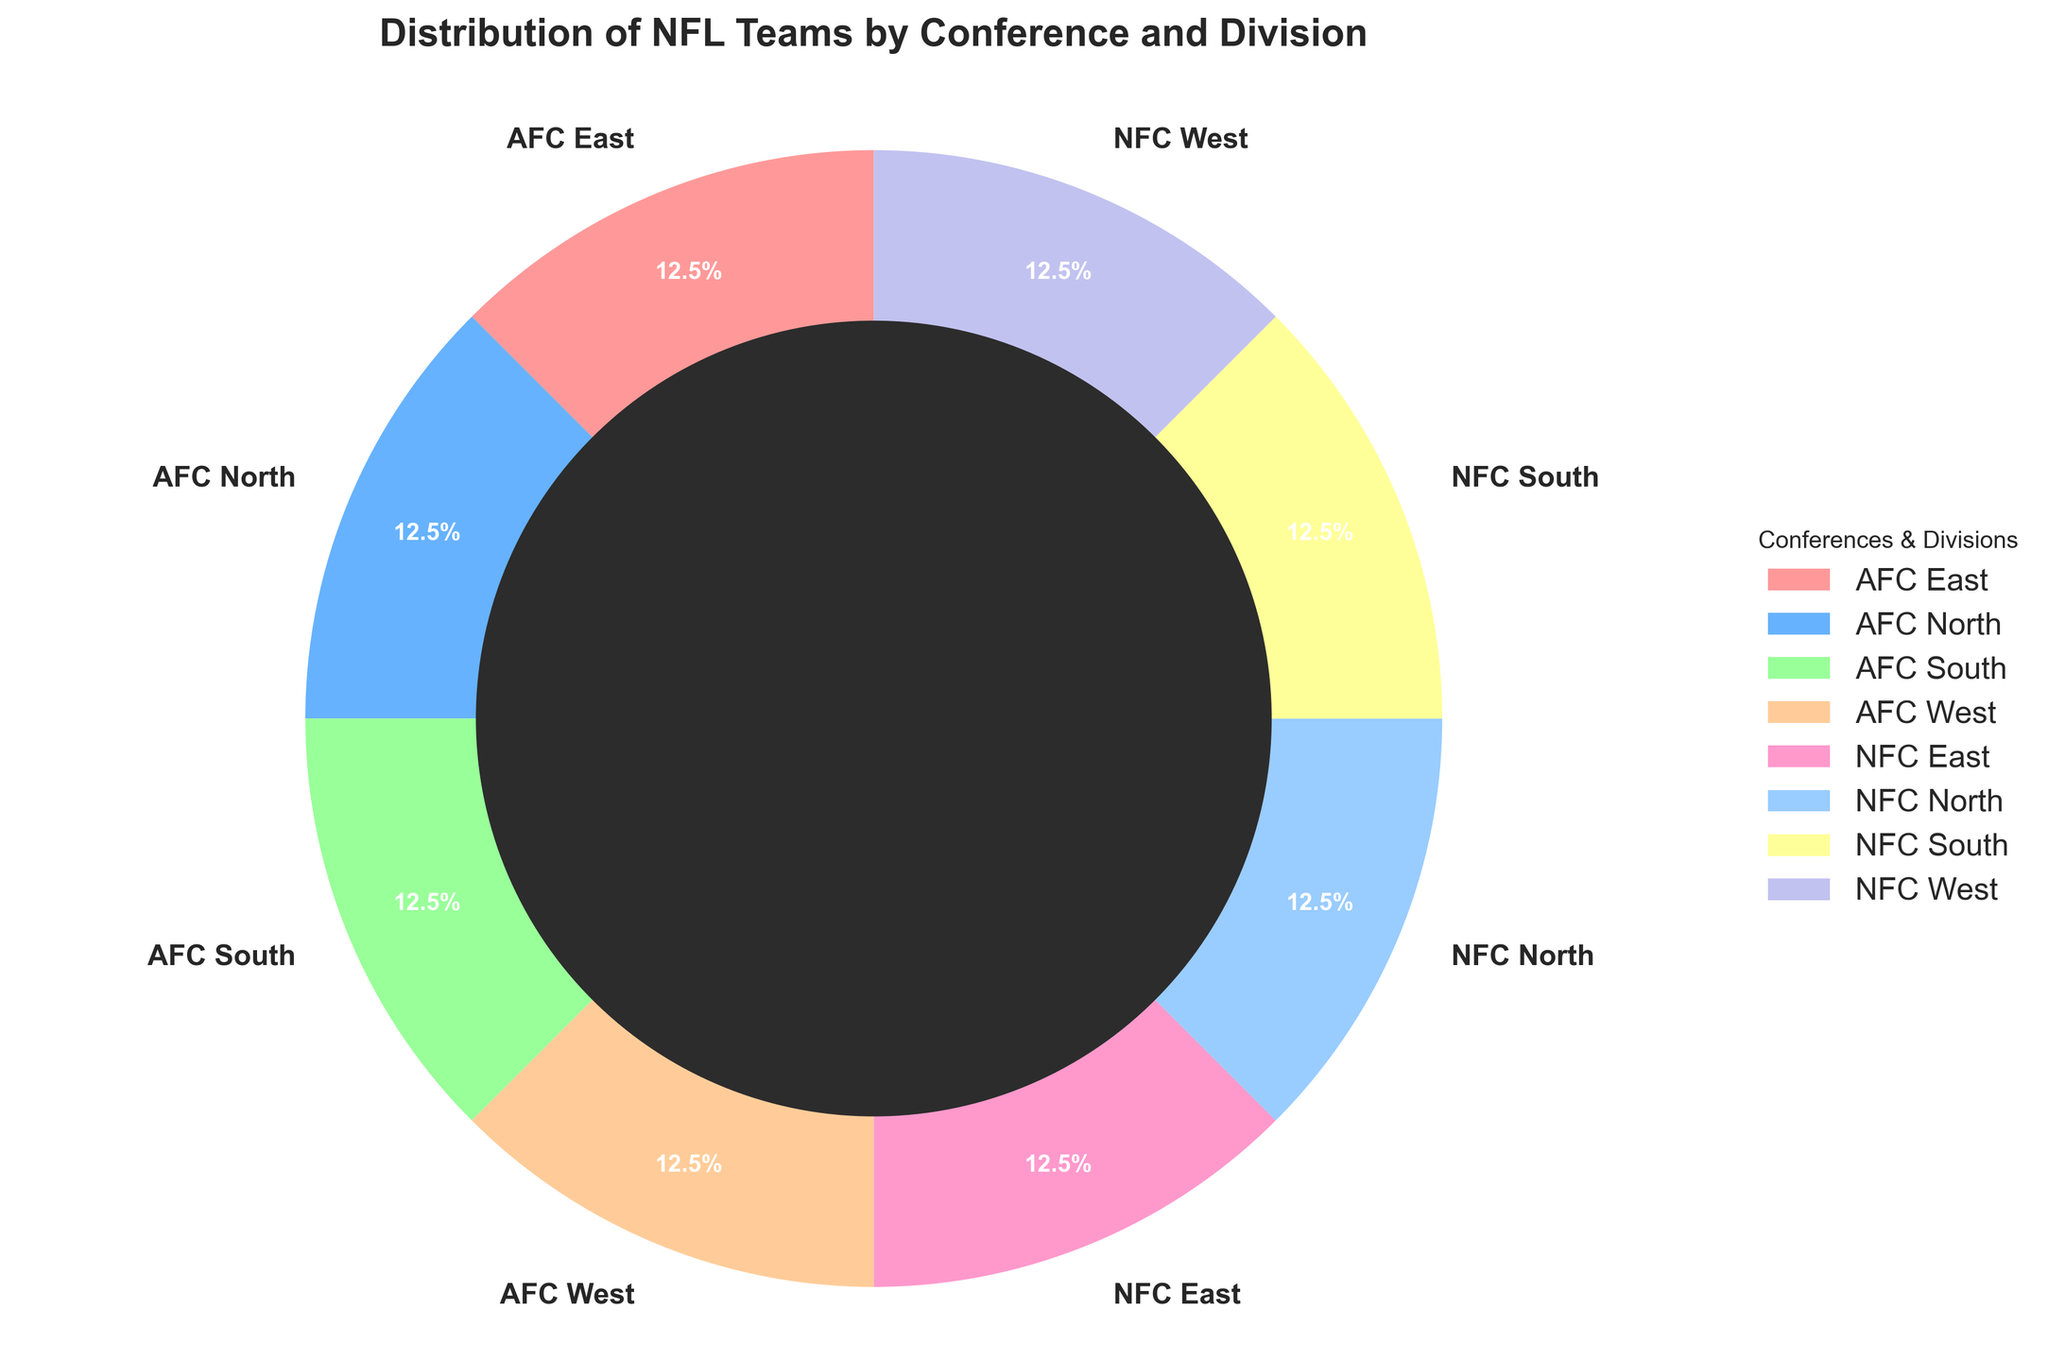what is the percentage of AFC teams? Adding up the AFC divisions (AFC East, AFC North, AFC South, and AFC West), there are 4 teams each, making a total of 16 teams. The total number of teams in the pie chart is 32, so the percentage is (16/32) * 100.
Answer: 50% What is the percentage of NFC East teams? Each division has 4 teams, and since NFC East is one division out of the 8 total divisions, it has (4/32) * 100 percent representation in the pie chart.
Answer: 12.5% How many teams belong to the South divisions across both conferences? Adding the teams from AFC South (4 teams) and NFC South (4 teams), we have a total of 4 + 4 teams in the South divisions.
Answer: 8 Which divisions have the same number of teams? All divisions (AFC East, AFC North, AFC South, AFC West, NFC East, NFC North, NFC South, NFC West) have the same number of teams, which is 4.
Answer: All divisions What is the combined percentage of the East divisions? The AFC East and NFC East each have 4 teams. So together, they make up 8 teams out of the total 32 teams. The percentage is (8/32) * 100.
Answer: 25% Which segment has a color representing NFC North? Based on the custom colors and labels provided, the NFC North segment can be identified visually in the pie chart.
Answer: Light blue Which divisions occupy the largest and smallest segments? Since all divisions have the same number of teams (4), they have equal-sized segments in the pie chart.
Answer: All divisions are equal What is the percentage of the West divisions combined? Adding teams from AFC West (4 teams) and NFC West (4 teams), that's a total of 8 teams out of 32 in the West divisions. The percentage is (8/32) * 100.
Answer: 25% Which conference has more teams? Both AFC and NFC conferences have 4 divisions each with 4 teams per division, totaling 16 teams each.
Answer: Both conferences have equal teams What is the difference in the number of teams between the AFC East and the NFC East? Both AFC East and NFC East contain 4 teams each, thus the difference is 4 - 4.
Answer: 0 